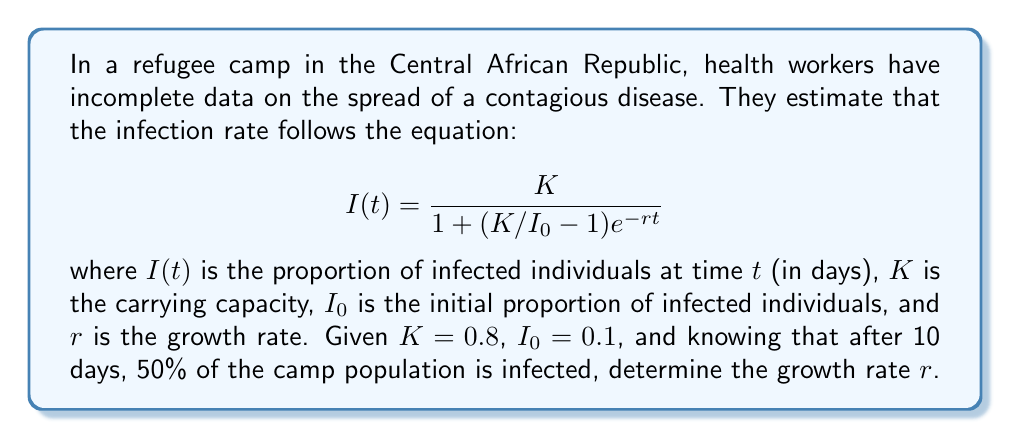Can you solve this math problem? To solve this inverse problem, we need to use the given information to determine the unknown parameter $r$. Let's approach this step-by-step:

1) We know that after 10 days, 50% of the population is infected. This means:

   $I(10) = 0.5$

2) We can substitute this into our equation:

   $$0.5 = \frac{0.8}{1 + (0.8/0.1 - 1)e^{-10r}}$$

3) Let's simplify the right side:

   $$0.5 = \frac{0.8}{1 + 7e^{-10r}}$$

4) Multiply both sides by the denominator:

   $$0.5(1 + 7e^{-10r}) = 0.8$$

5) Expand the left side:

   $$0.5 + 3.5e^{-10r} = 0.8$$

6) Subtract 0.5 from both sides:

   $$3.5e^{-10r} = 0.3$$

7) Divide both sides by 3.5:

   $$e^{-10r} = \frac{0.3}{3.5} = \frac{6}{70}$$

8) Take the natural logarithm of both sides:

   $$-10r = \ln(\frac{6}{70})$$

9) Divide both sides by -10:

   $$r = -\frac{1}{10}\ln(\frac{6}{70})$$

10) Calculate the final value:

    $$r \approx 0.2466$$

Therefore, the growth rate $r$ is approximately 0.2466 per day.
Answer: $r \approx 0.2466$ per day 